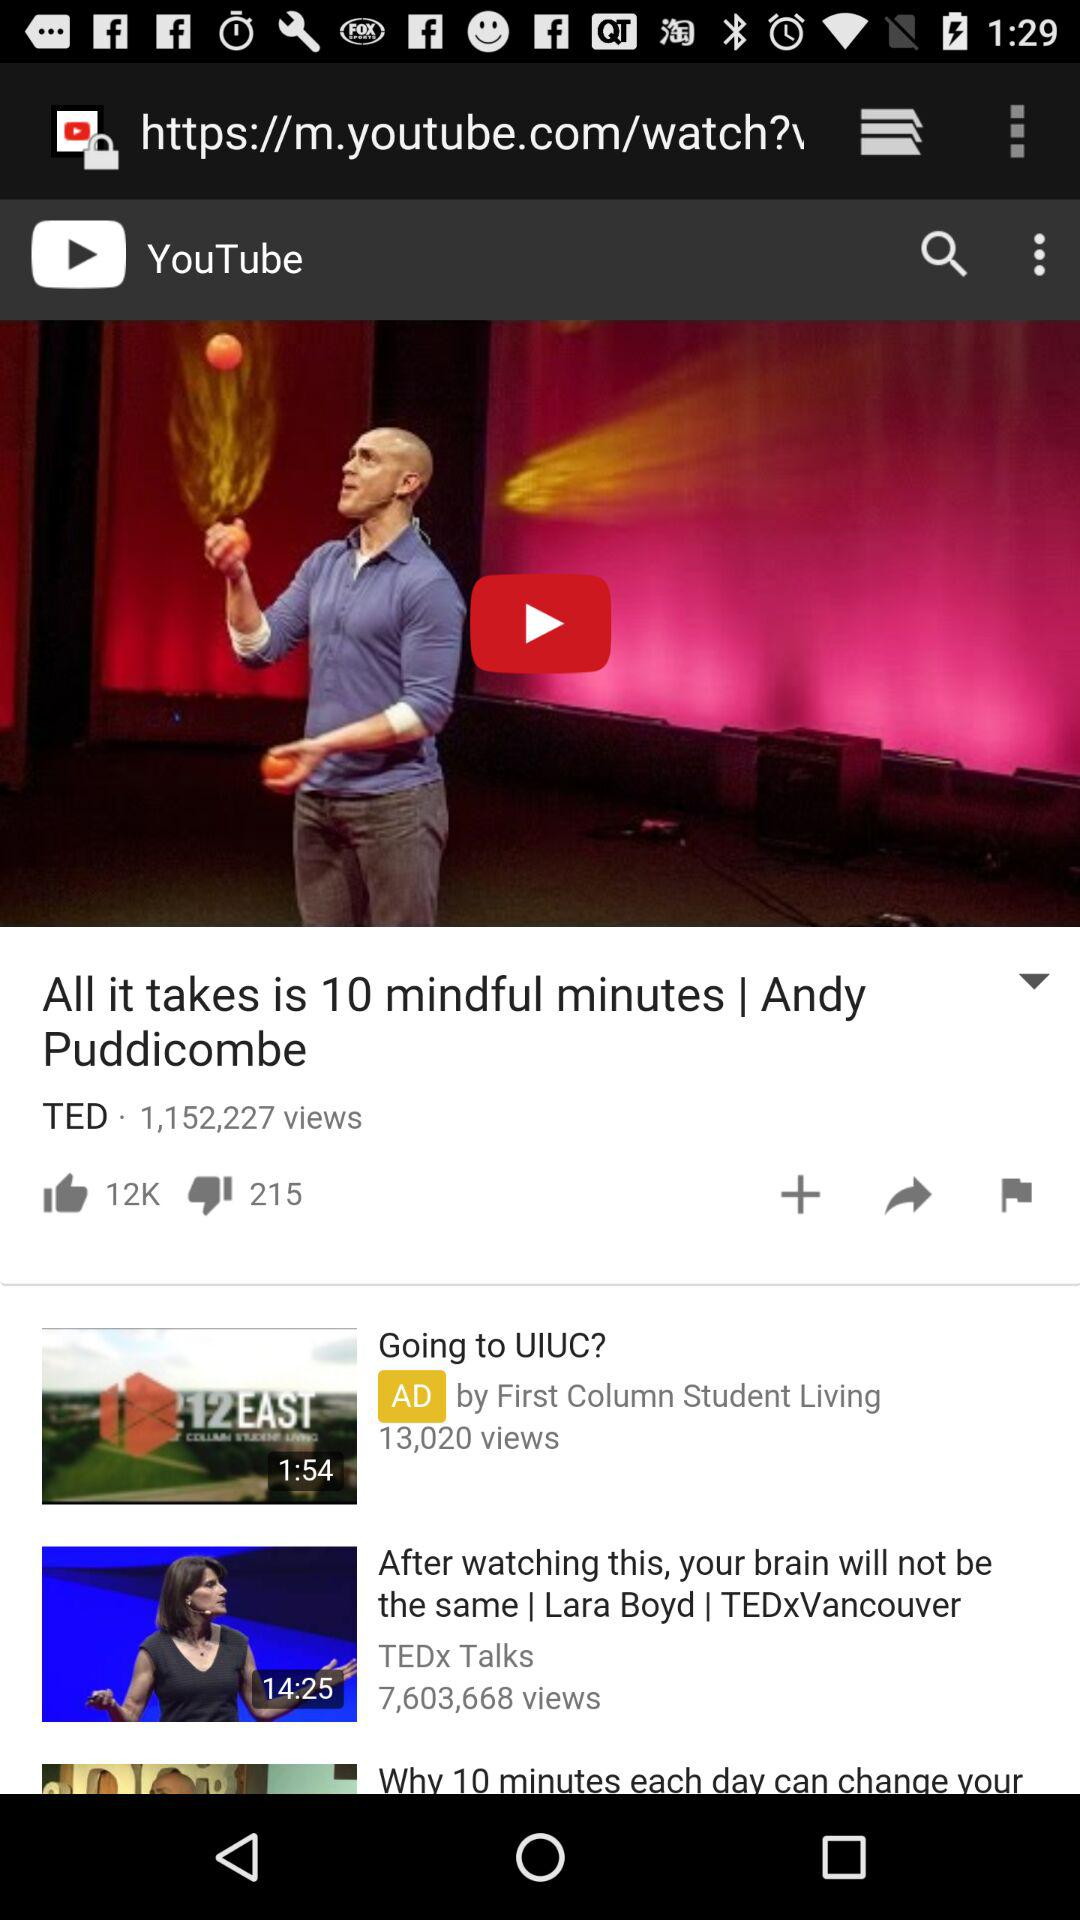How many thumbs up does the video have?
Answer the question using a single word or phrase. 12K 